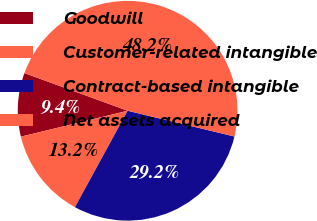<chart> <loc_0><loc_0><loc_500><loc_500><pie_chart><fcel>Goodwill<fcel>Customer-related intangible<fcel>Contract-based intangible<fcel>Net assets acquired<nl><fcel>9.36%<fcel>13.25%<fcel>29.19%<fcel>48.2%<nl></chart> 